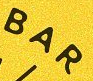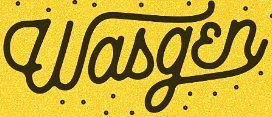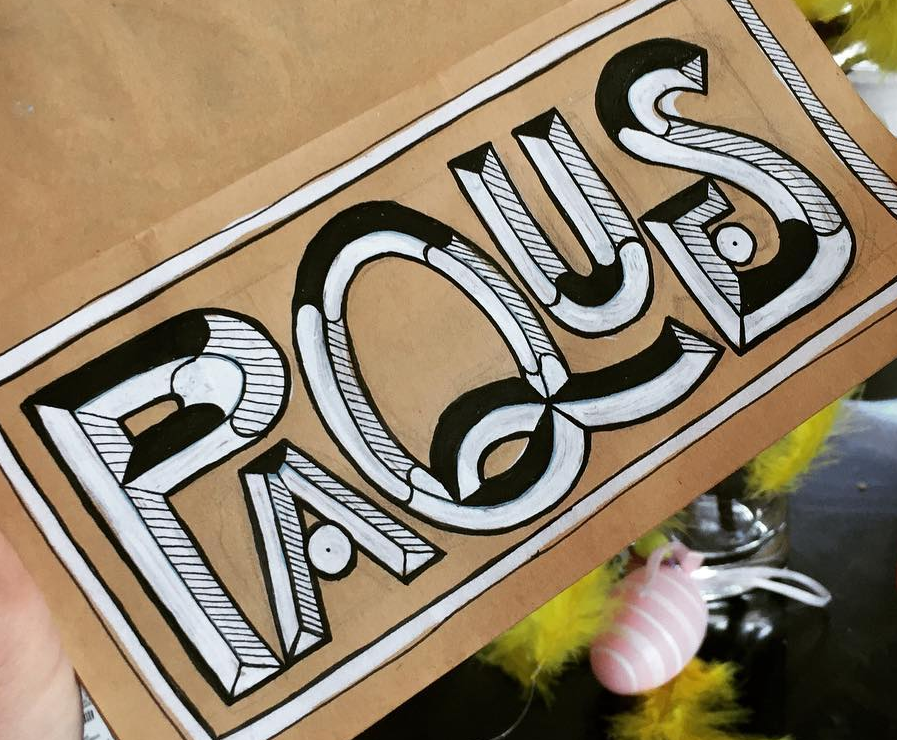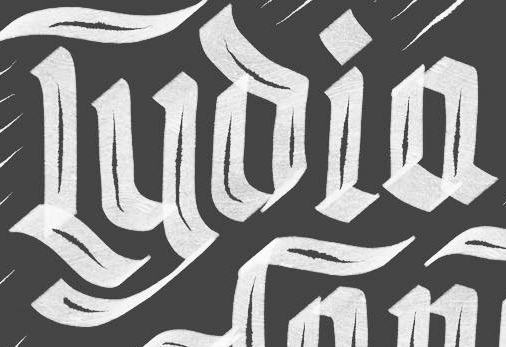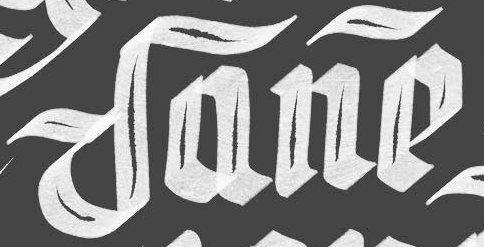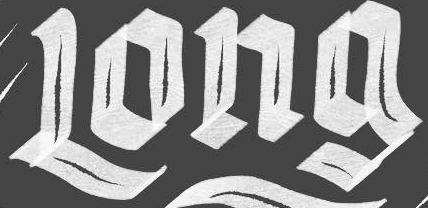What words are shown in these images in order, separated by a semicolon? BAR; Wasgɛn; PAQUES; Lyoia; Dane; Long 